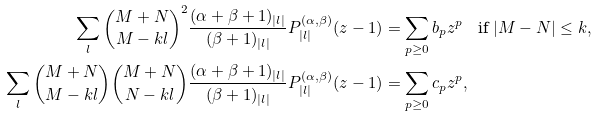<formula> <loc_0><loc_0><loc_500><loc_500>\sum _ { l } { M + N \choose M - k l } ^ { 2 } \frac { ( \alpha + \beta + 1 ) _ { | l | } } { ( \beta + 1 ) _ { | l | } } P _ { | l | } ^ { ( \alpha , \beta ) } ( z - 1 ) & = \sum _ { p \geq 0 } b _ { p } z ^ { p } \quad \text {if $|M-N|\leq k$} , \\ \sum _ { l } { M + N \choose M - k l } { M + N \choose N - k l } \frac { ( \alpha + \beta + 1 ) _ { | l | } } { ( \beta + 1 ) _ { | l | } } P _ { | l | } ^ { ( \alpha , \beta ) } ( z - 1 ) & = \sum _ { p \geq 0 } c _ { p } z ^ { p } ,</formula> 